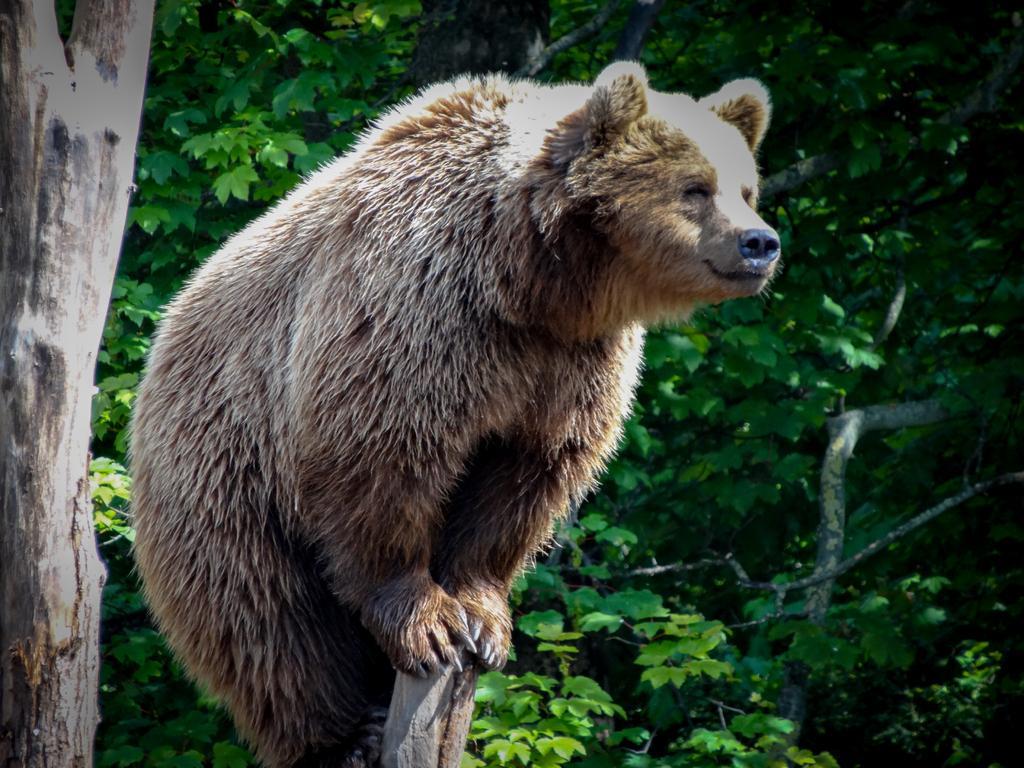In one or two sentences, can you explain what this image depicts? In this picture who is standing on the wooden stick. In the background i can see the trees and plants. 